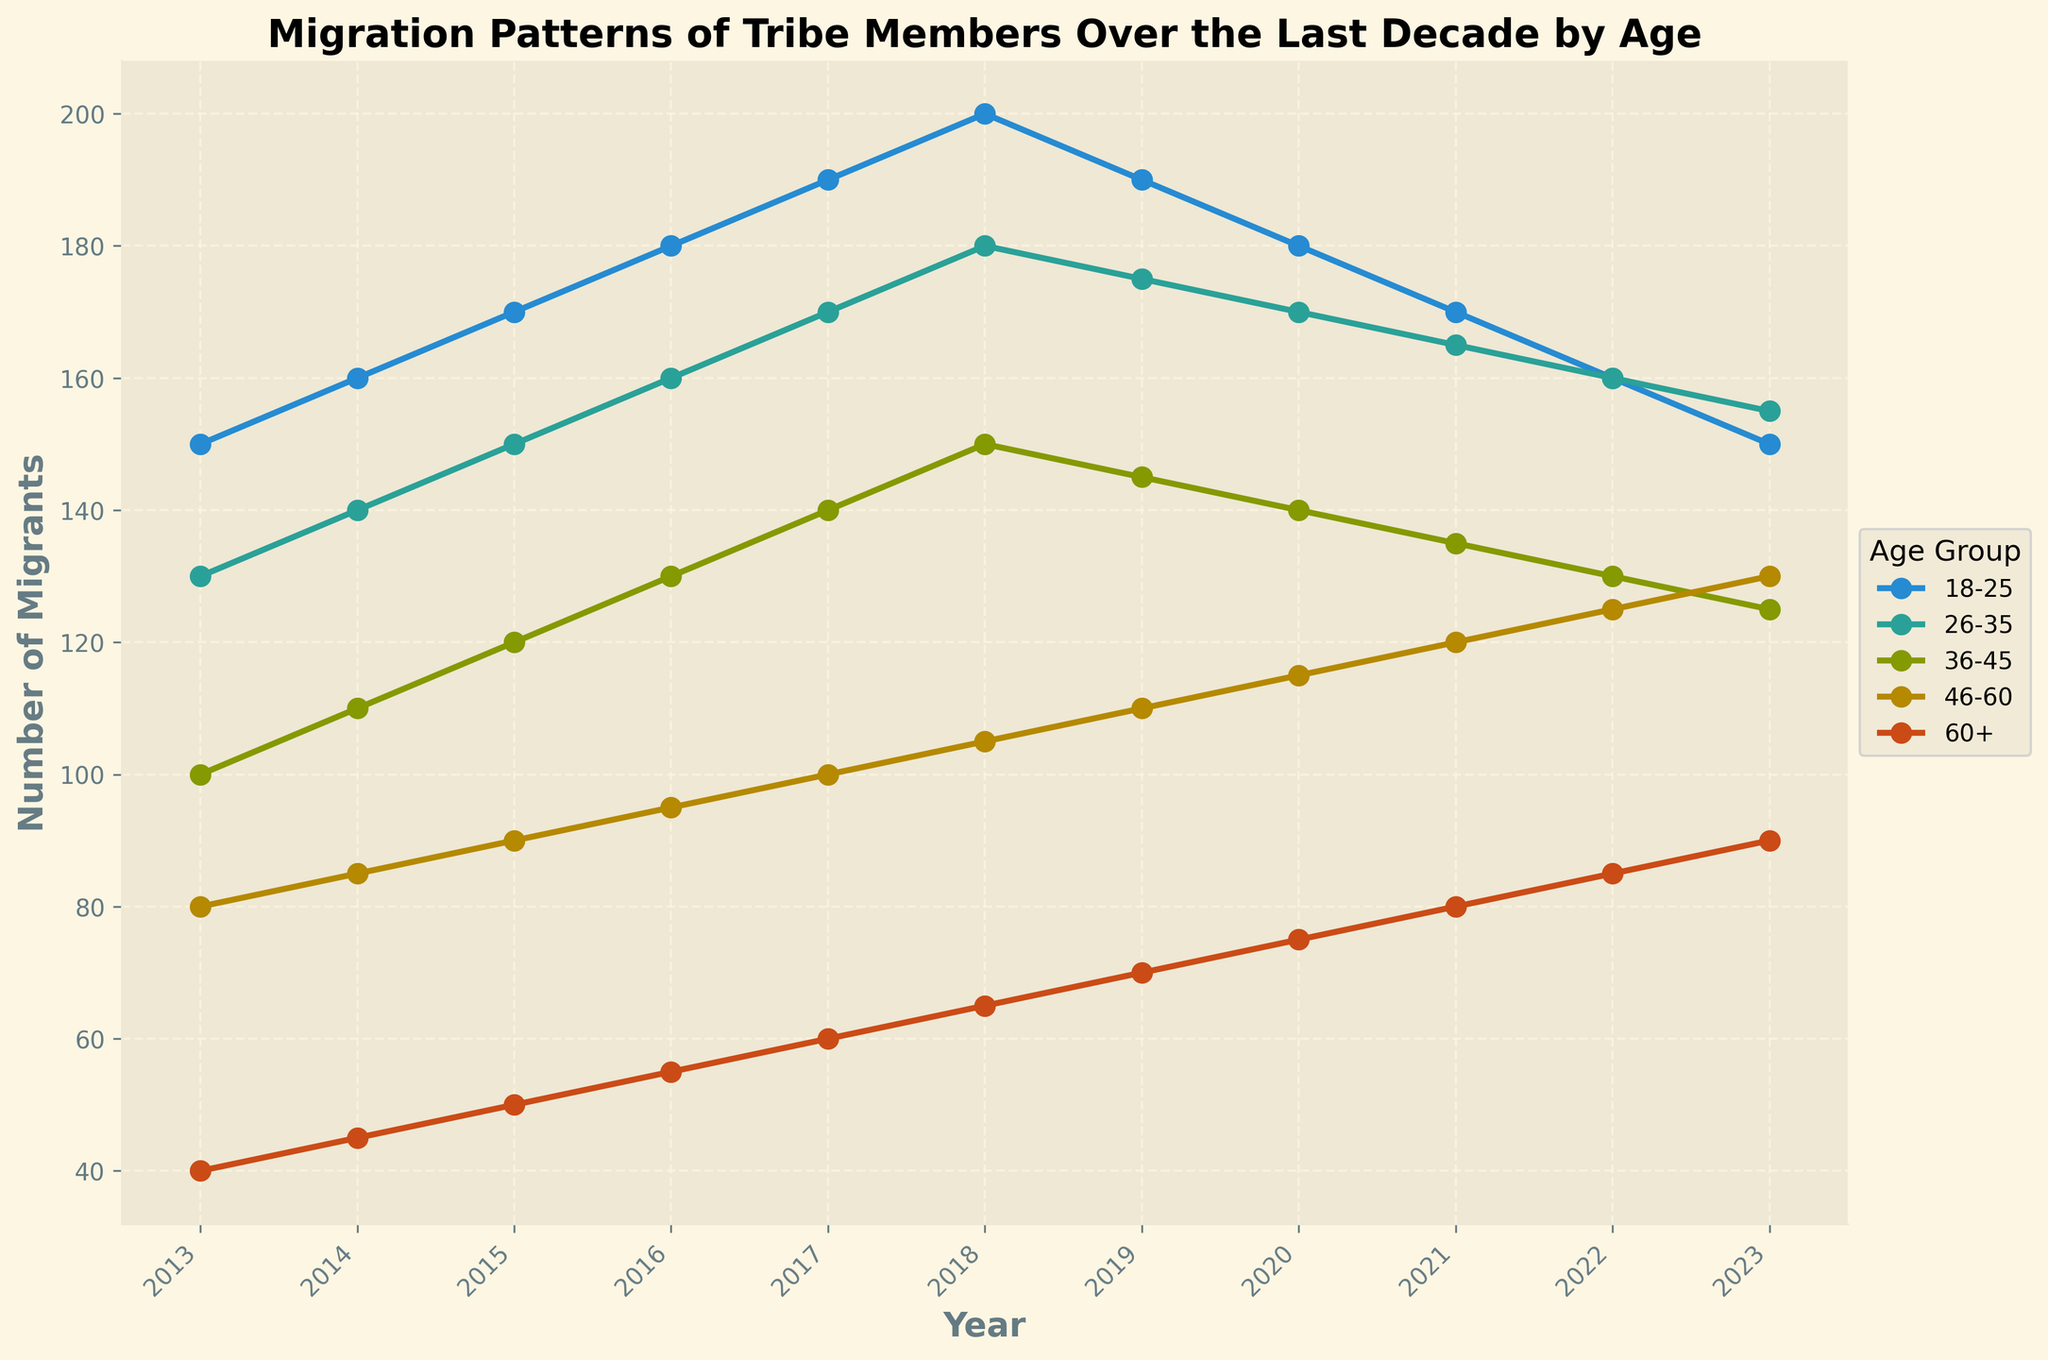What is the title of the plot? The title is usually found at the top of the plot, indicating the main subject or the scope of the information. In this figure, it's "Migration Patterns of Tribe Members Over the Last Decade by Age".
Answer: Migration Patterns of Tribe Members Over the Last Decade by Age What is the x-axis representing? The x-axis typically shows the independent variable. For this plot, it represents the years from 2013 to 2023.
Answer: Year How many different age groups are depicted in the plot? Count the number of distinct lines or labels in the legend, each representing a different age group. Here, there are five age groups.
Answer: Five Which age group had the highest number of migrants in 2023? Look at the y-axis readings for each age group's line in the year 2023. The highest point among all age groups in 2023 is the 60+ group.
Answer: 60+ What can we infer about the trend of the 18-25 age group's migration from 2013 to 2023? Observing the plot's line for the 18-25 group, we see it starts high, peaks around 2018, and then gradually declines until 2023.
Answer: Increased initially, then decreased In which year did the 36-45 age group see the highest number of migrants? Trace the line for the 36-45 age group and find the highest point on the y-axis among all years. It peaks in 2018.
Answer: 2018 Calculate the average number of migrants for the 46-60 age group over the decade. Sum up the number of migrants for each year (80 + 85 + 90 + 95 + 100 + 105 + 110 + 115 + 120 + 125 + 130), then divide by the number of years (11). This yields an average.
Answer: 103.27 Compare the migration patterns between the 26-35 and 60+ age groups. Which group saw more growth, and by what number? Calculate the difference in the number of migrants from 2013 to 2023 for both age groups: (155 - 130 for 26-35) and (90 - 40 for 60+). The 60+ group grew by 50, while the 26-35 group grew by 25. So, the 60+ group saw more growth by 25 migrants.
Answer: 60+ by 25 migrants 